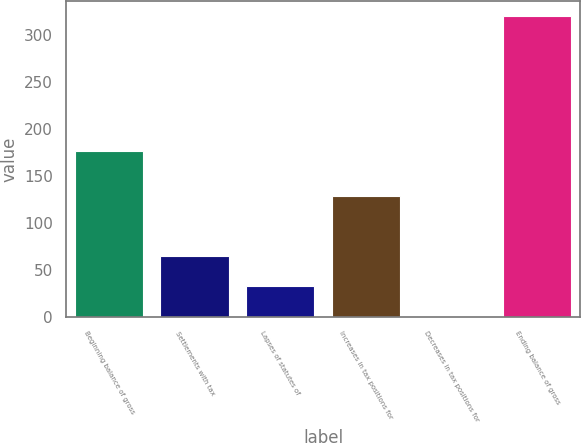Convert chart. <chart><loc_0><loc_0><loc_500><loc_500><bar_chart><fcel>Beginning balance of gross<fcel>Settlements with tax<fcel>Lapses of statutes of<fcel>Increases in tax positions for<fcel>Decreases in tax positions for<fcel>Ending balance of gross<nl><fcel>177<fcel>64.8<fcel>32.9<fcel>128.6<fcel>1<fcel>320<nl></chart> 